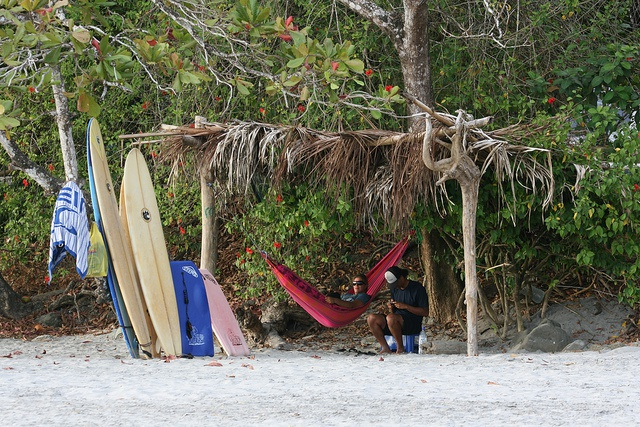Describe the objects in this image and their specific colors. I can see surfboard in khaki, tan, and gray tones, surfboard in khaki, tan, and beige tones, people in khaki, black, maroon, and gray tones, surfboard in khaki, blue, darkblue, and navy tones, and surfboard in khaki, lightpink, darkgray, pink, and lightgray tones in this image. 